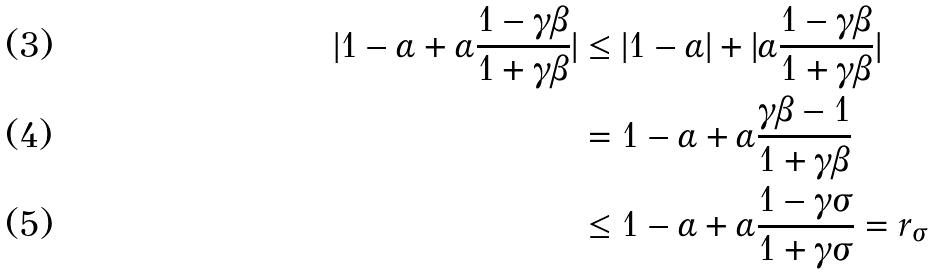Convert formula to latex. <formula><loc_0><loc_0><loc_500><loc_500>| 1 - \alpha + \alpha \frac { 1 - \gamma \beta } { 1 + \gamma \beta } | & \leq | 1 - \alpha | + | \alpha \frac { 1 - \gamma \beta } { 1 + \gamma \beta } | \\ & = 1 - \alpha + \alpha \frac { \gamma \beta - 1 } { 1 + \gamma \beta } \\ & \leq 1 - \alpha + \alpha \frac { 1 - \gamma \sigma } { 1 + \gamma \sigma } = r _ { \sigma }</formula> 